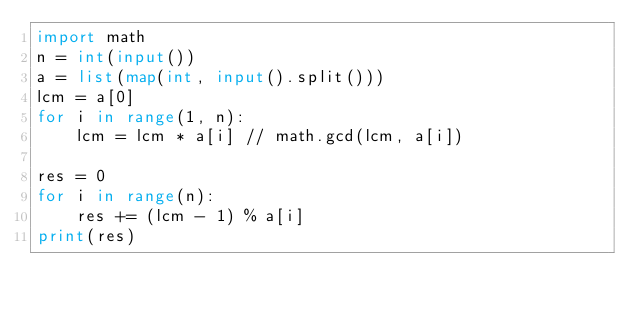Convert code to text. <code><loc_0><loc_0><loc_500><loc_500><_Python_>import math
n = int(input())
a = list(map(int, input().split()))
lcm = a[0]
for i in range(1, n):
    lcm = lcm * a[i] // math.gcd(lcm, a[i])

res = 0
for i in range(n):
    res += (lcm - 1) % a[i]
print(res)</code> 